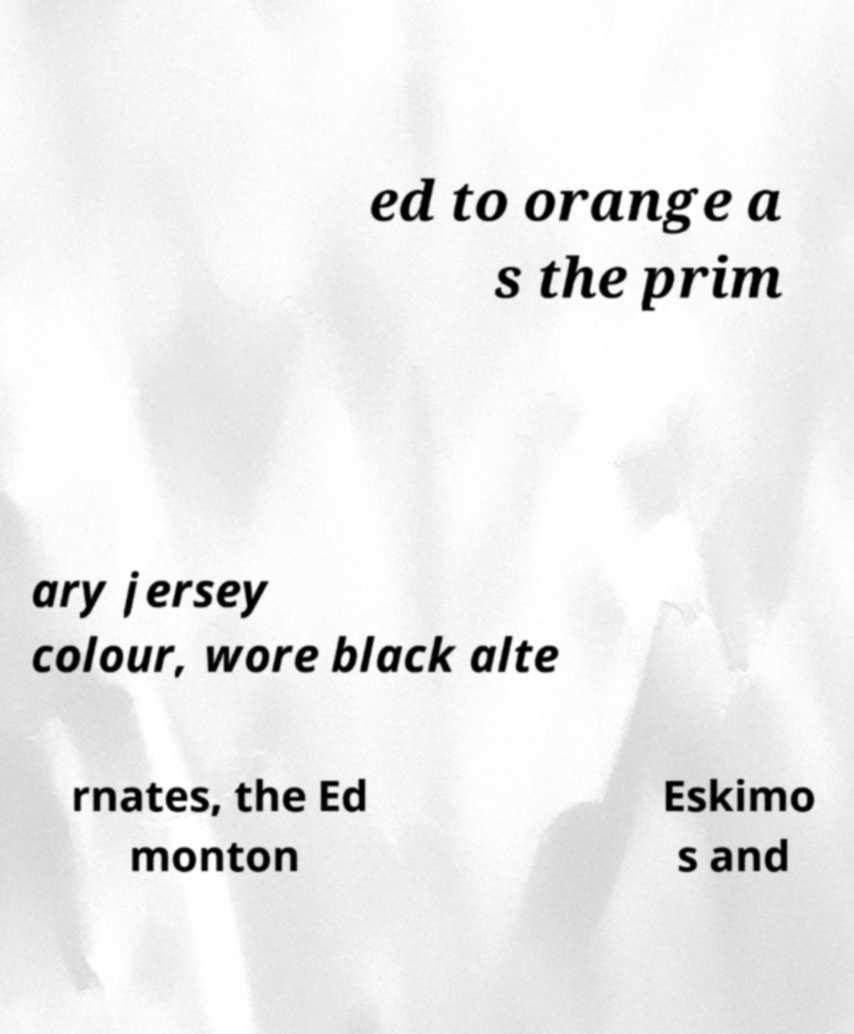Could you assist in decoding the text presented in this image and type it out clearly? ed to orange a s the prim ary jersey colour, wore black alte rnates, the Ed monton Eskimo s and 